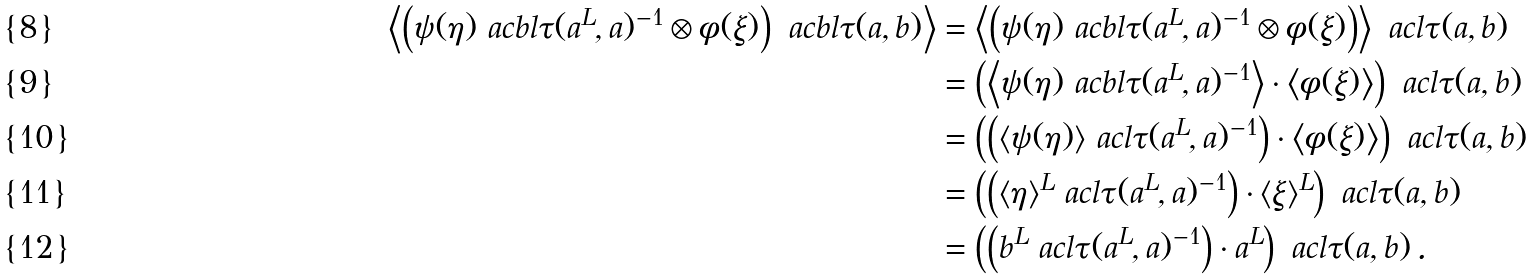<formula> <loc_0><loc_0><loc_500><loc_500>\left \langle \left ( \psi ( \eta ) \ a c b l \tau ( a ^ { L } , a ) ^ { - 1 } \otimes \phi ( \xi ) \right ) \ a c b l \tau ( a , b ) \right \rangle & = \left \langle \left ( \psi ( \eta ) \ a c b l \tau ( a ^ { L } , a ) ^ { - 1 } \otimes \phi ( \xi ) \right ) \right \rangle \ a c l \tau ( a , b ) \\ & = \left ( \left \langle \psi ( \eta ) \ a c b l \tau ( a ^ { L } , a ) ^ { - 1 } \right \rangle \cdot \left \langle \phi ( \xi ) \right \rangle \right ) \ a c l \tau ( a , b ) \\ & = \left ( \left ( \langle \psi ( \eta ) \rangle \ a c l \tau ( a ^ { L } , a ) ^ { - 1 } \right ) \cdot \left \langle \phi ( \xi ) \right \rangle \right ) \ a c l \tau ( a , b ) \\ & = \left ( \left ( \langle \eta \rangle ^ { L } \ a c l \tau ( a ^ { L } , a ) ^ { - 1 } \right ) \cdot \langle \xi \rangle ^ { L } \right ) \ a c l \tau ( a , b ) \\ & = \left ( \left ( b ^ { L } \ a c l \tau ( a ^ { L } , a ) ^ { - 1 } \right ) \cdot a ^ { L } \right ) \ a c l \tau ( a , b ) \, .</formula> 